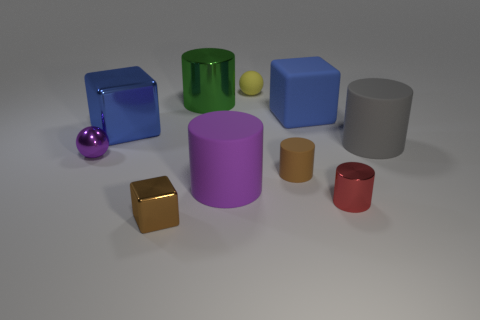Subtract all gray cylinders. Subtract all yellow cubes. How many cylinders are left? 4 Subtract all spheres. How many objects are left? 8 Subtract 0 yellow cylinders. How many objects are left? 10 Subtract all tiny cyan rubber balls. Subtract all big green metallic cylinders. How many objects are left? 9 Add 1 large shiny cylinders. How many large shiny cylinders are left? 2 Add 1 small matte cylinders. How many small matte cylinders exist? 2 